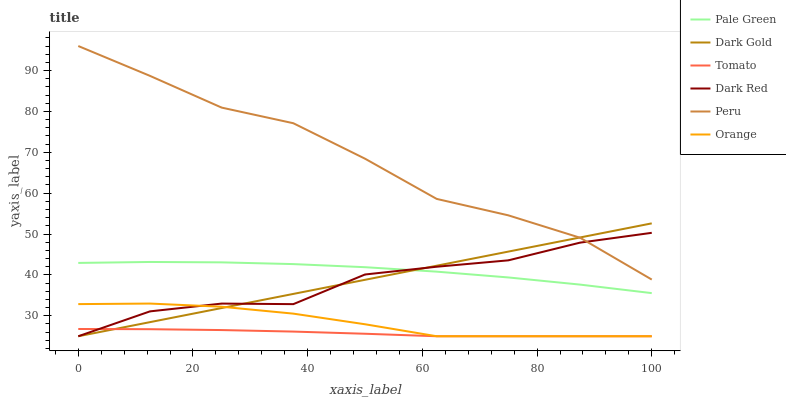Does Tomato have the minimum area under the curve?
Answer yes or no. Yes. Does Peru have the maximum area under the curve?
Answer yes or no. Yes. Does Dark Gold have the minimum area under the curve?
Answer yes or no. No. Does Dark Gold have the maximum area under the curve?
Answer yes or no. No. Is Dark Gold the smoothest?
Answer yes or no. Yes. Is Dark Red the roughest?
Answer yes or no. Yes. Is Dark Red the smoothest?
Answer yes or no. No. Is Dark Gold the roughest?
Answer yes or no. No. Does Tomato have the lowest value?
Answer yes or no. Yes. Does Pale Green have the lowest value?
Answer yes or no. No. Does Peru have the highest value?
Answer yes or no. Yes. Does Dark Gold have the highest value?
Answer yes or no. No. Is Pale Green less than Peru?
Answer yes or no. Yes. Is Peru greater than Pale Green?
Answer yes or no. Yes. Does Orange intersect Tomato?
Answer yes or no. Yes. Is Orange less than Tomato?
Answer yes or no. No. Is Orange greater than Tomato?
Answer yes or no. No. Does Pale Green intersect Peru?
Answer yes or no. No. 